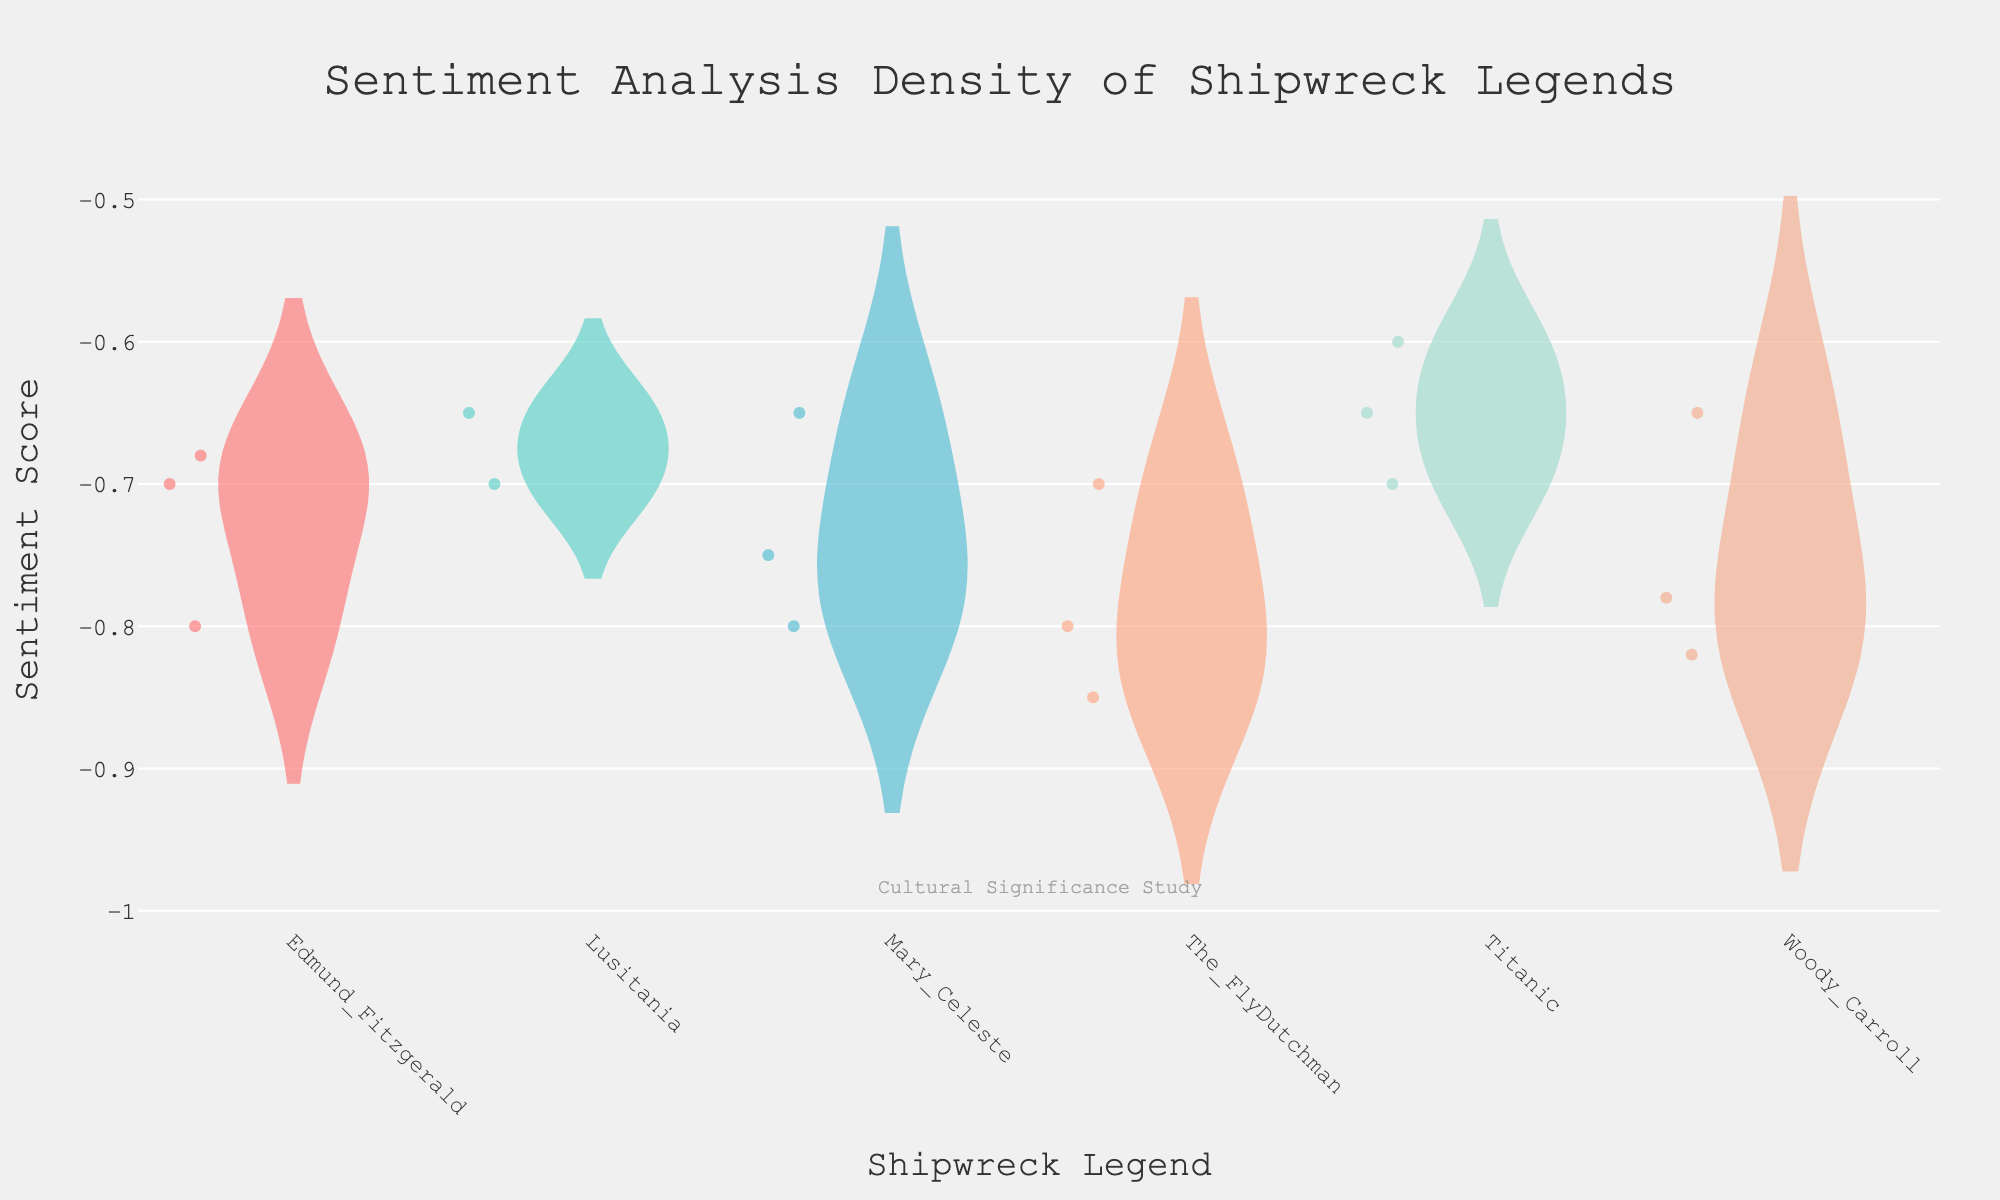What's the title of the plot? The title is typically located at the top of the plot. Its purpose is to provide a brief description of what the plot is showing. In this case, the title is "Sentiment Analysis Density of Shipwreck Legends."
Answer: Sentiment Analysis Density of Shipwreck Legends Which shipwreck legend has the lowest average sentiment score? To determine this, look at the mean lines in each violin plot. The shipwreck legend with the mean line closest to the bottom will have the lowest average sentiment score.
Answer: Woody Carroll Which shipwreck legend shows the greatest variability in sentiment scores? Variability in a violin plot can be assessed by the width and spread of the plot. The legend with the widest and most spread-out violin plot has the greatest variability in sentiment scores.
Answer: Woody Carroll What is the sentiment range of the Titanic legend based on the plot? Examine the top and bottom of the Titanic's violin plot. The range is the distance from the top (maximum sentiment score) to the bottom (minimum sentiment score).
Answer: -0.6 to -0.7 Are there any shipwreck legends with sentiment scores consistently below -0.65? To answer this, identify any violin plots where all the points are below -0.65. By observation, Woody Carroll meets this criterion.
Answer: Yes, Woody Carroll Which shipwreck legend has sentiment scores closest to -0.8? Look for violin plots whose mean lines and majority of data points are around -0.8. The FlyDutchman and Edmund Fitzgerald are the legends that fit this description.
Answer: The FlyDutchman, Edmund Fitzgerald Is there a shipwreck legend with any sentiment scores above -0.6? To find this information, examine if any part of any violin plot extends above -0.6. No violin plot extends above -0.6, indicating no sentiment scores in that range.
Answer: No Which shipwreck legends have mean sentiment scores higher than -0.7? Look at the mean lines in the violin plots. Legends whose mean line is above -0.7 have mean sentiment scores higher than -0.7.
Answer: Titanic, Lusitania How do the sentiment scores of Titanic and Lusitania compare? Compare the placement of the mean lines and the spread of sentiment scores. Both Titanic and Lusitania have mean sentiment scores around -0.65, but the spread of Lusitania seems slightly smaller.
Answer: They are similar 